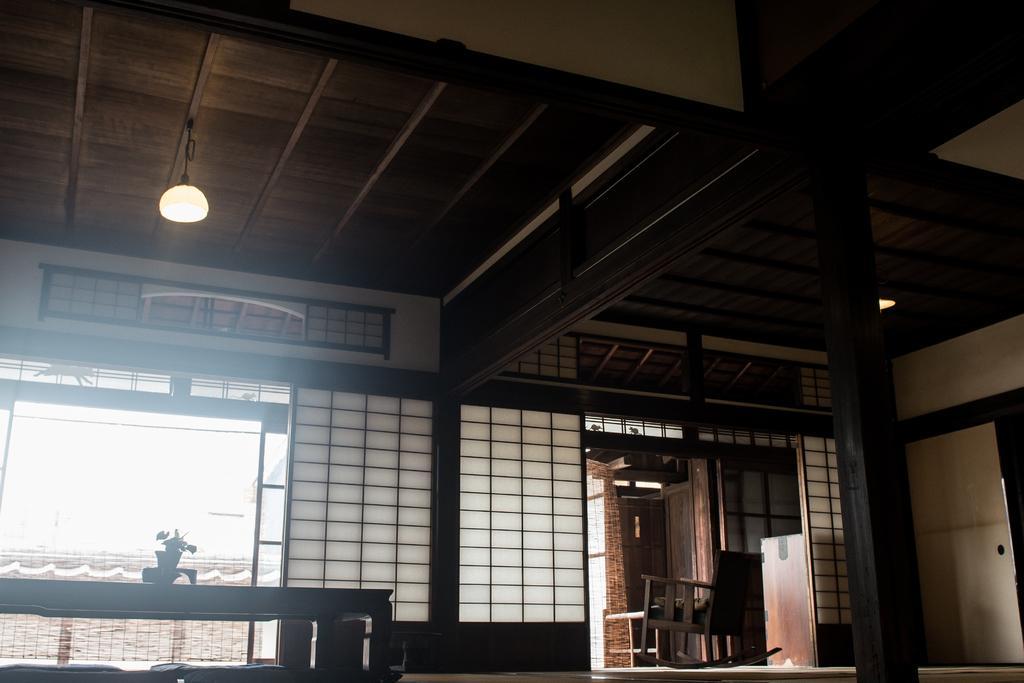Could you give a brief overview of what you see in this image? In this image I can see inside view of a room. On the top side of this image I can see few lights on the ceiling. On the right side I can see a chair and on the left side of this image I can see a table and on it I can see a plant. 